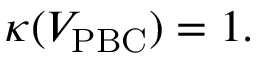<formula> <loc_0><loc_0><loc_500><loc_500>\kappa ( V _ { P B C } ) = 1 .</formula> 